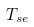<formula> <loc_0><loc_0><loc_500><loc_500>T _ { s e }</formula> 